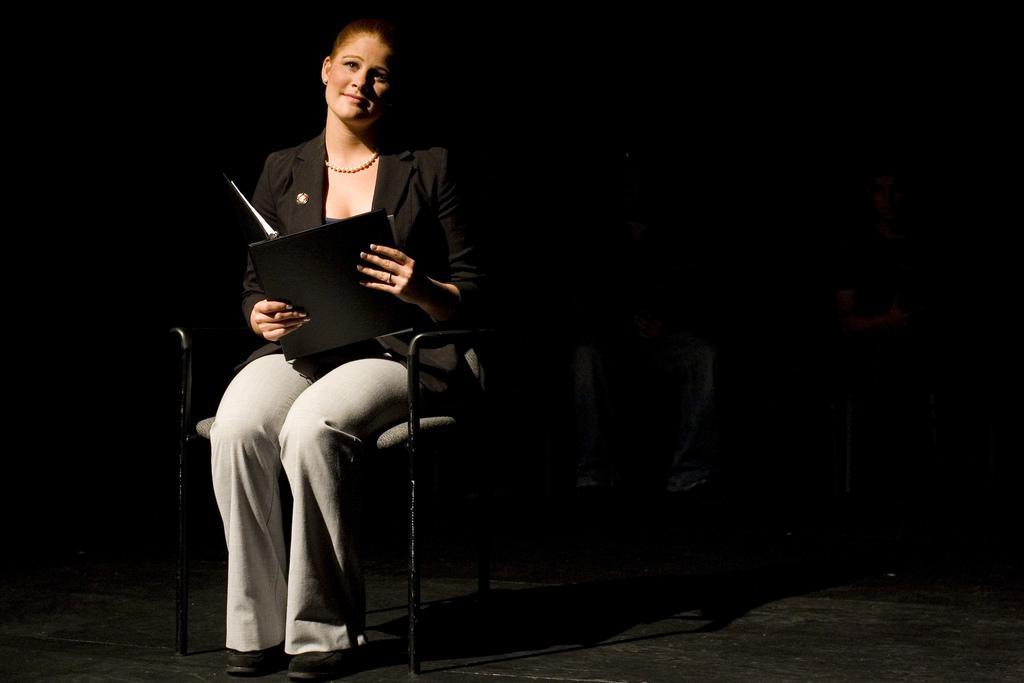How would you summarize this image in a sentence or two? In this picture I can see a woman is sitting on a chair. The woman is wearing a necklace, black color jacket and white color pant. The background is dark. 